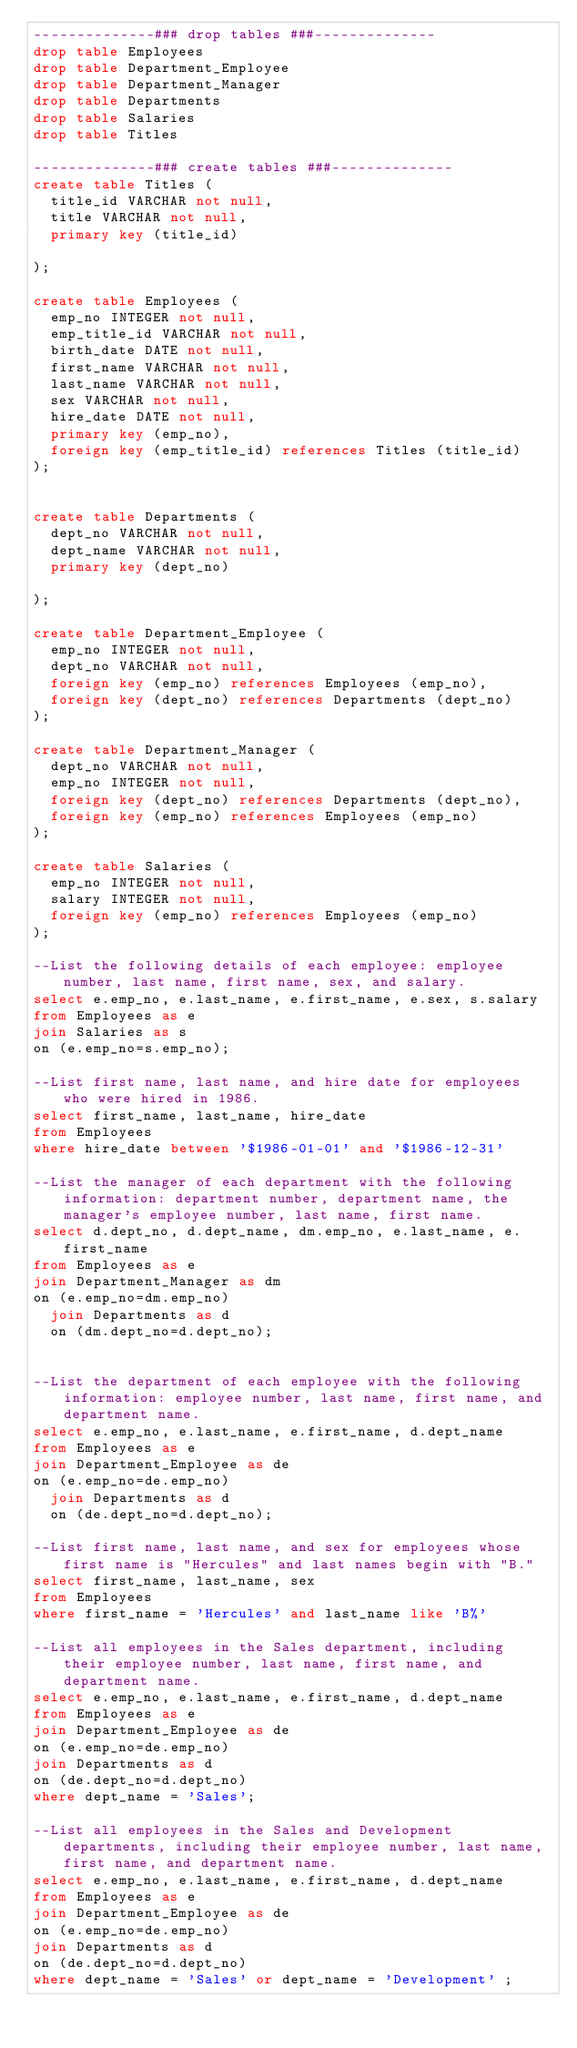<code> <loc_0><loc_0><loc_500><loc_500><_SQL_>--------------### drop tables ###--------------
drop table Employees
drop table Department_Employee 
drop table Department_Manager 
drop table Departments 
drop table Salaries 
drop table Titles 

--------------### create tables ###--------------
create table Titles (
	title_id VARCHAR not null,  
	title VARCHAR not null,
	primary key (title_id)

);

create table Employees (
	emp_no INTEGER not null,
	emp_title_id VARCHAR not null,
	birth_date DATE not null,
	first_name VARCHAR not null,
	last_name VARCHAR not null,	
	sex VARCHAR not null,
	hire_date DATE not null,
	primary key (emp_no),
	foreign key (emp_title_id) references Titles (title_id)
);


create table Departments (
	dept_no VARCHAR not null,
	dept_name VARCHAR not null,
	primary key (dept_no)

);

create table Department_Employee (
	emp_no INTEGER not null,
	dept_no VARCHAR not null,
	foreign key (emp_no) references Employees (emp_no),
	foreign key (dept_no) references Departments (dept_no)	
);

create table Department_Manager (
	dept_no VARCHAR not null, 
	emp_no INTEGER not null,
	foreign key (dept_no) references Departments (dept_no),	
	foreign key (emp_no) references Employees (emp_no)
);

create table Salaries (
	emp_no INTEGER not null,
	salary INTEGER not null,
	foreign key (emp_no) references Employees (emp_no)
);

--List the following details of each employee: employee number, last name, first name, sex, and salary.
select e.emp_no, e.last_name, e.first_name, e.sex, s.salary
from Employees as e 
join Salaries as s
on (e.emp_no=s.emp_no);

--List first name, last name, and hire date for employees who were hired in 1986.
select first_name, last_name, hire_date 
from Employees 
where hire_date between '$1986-01-01' and '$1986-12-31'

--List the manager of each department with the following information: department number, department name, the manager's employee number, last name, first name.
select d.dept_no, d.dept_name, dm.emp_no, e.last_name, e.first_name
from Employees as e 
join Department_Manager as dm
on (e.emp_no=dm.emp_no)
	join Departments as d
	on (dm.dept_no=d.dept_no);


--List the department of each employee with the following information: employee number, last name, first name, and department name.
select e.emp_no, e.last_name, e.first_name, d.dept_name
from Employees as e 
join Department_Employee as de
on (e.emp_no=de.emp_no)
	join Departments as d
	on (de.dept_no=d.dept_no);

--List first name, last name, and sex for employees whose first name is "Hercules" and last names begin with "B."
select first_name, last_name, sex
from Employees
where first_name = 'Hercules' and last_name like 'B%'

--List all employees in the Sales department, including their employee number, last name, first name, and department name.
select e.emp_no, e.last_name, e.first_name, d.dept_name
from Employees as e
join Department_Employee as de
on (e.emp_no=de.emp_no)
join Departments as d
on (de.dept_no=d.dept_no)
where dept_name = 'Sales';

--List all employees in the Sales and Development departments, including their employee number, last name, first name, and department name.
select e.emp_no, e.last_name, e.first_name, d.dept_name
from Employees as e
join Department_Employee as de
on (e.emp_no=de.emp_no)
join Departments as d
on (de.dept_no=d.dept_no)
where dept_name = 'Sales' or dept_name = 'Development' ;
</code> 